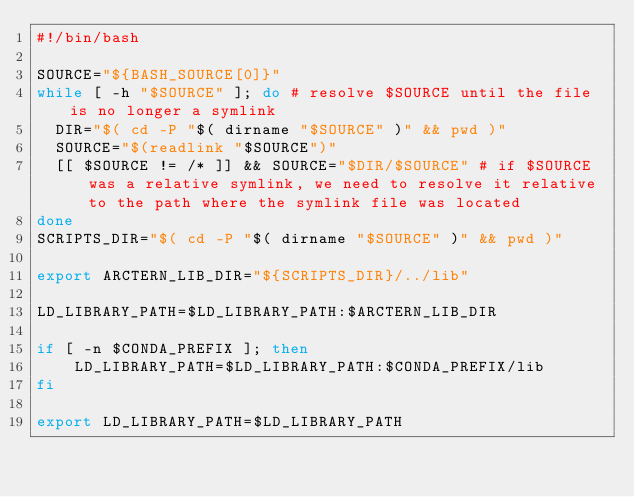Convert code to text. <code><loc_0><loc_0><loc_500><loc_500><_Bash_>#!/bin/bash

SOURCE="${BASH_SOURCE[0]}"
while [ -h "$SOURCE" ]; do # resolve $SOURCE until the file is no longer a symlink
  DIR="$( cd -P "$( dirname "$SOURCE" )" && pwd )"
  SOURCE="$(readlink "$SOURCE")"
  [[ $SOURCE != /* ]] && SOURCE="$DIR/$SOURCE" # if $SOURCE was a relative symlink, we need to resolve it relative to the path where the symlink file was located
done
SCRIPTS_DIR="$( cd -P "$( dirname "$SOURCE" )" && pwd )"

export ARCTERN_LIB_DIR="${SCRIPTS_DIR}/../lib"

LD_LIBRARY_PATH=$LD_LIBRARY_PATH:$ARCTERN_LIB_DIR

if [ -n $CONDA_PREFIX ]; then
    LD_LIBRARY_PATH=$LD_LIBRARY_PATH:$CONDA_PREFIX/lib
fi

export LD_LIBRARY_PATH=$LD_LIBRARY_PATH

</code> 